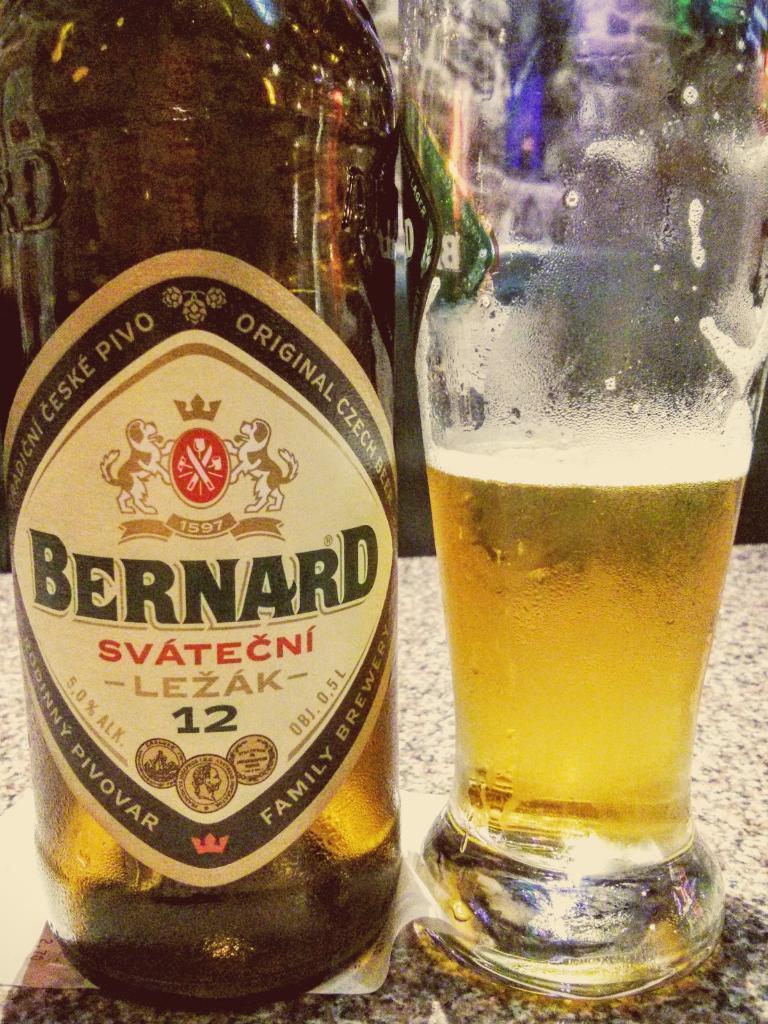Which brewery made this drink?
Your answer should be compact. Bernard. What is the numerical number written in the bottle?
Offer a terse response. 12. 